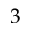<formula> <loc_0><loc_0><loc_500><loc_500>3</formula> 